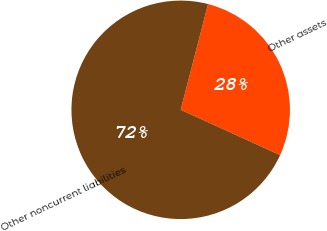<chart> <loc_0><loc_0><loc_500><loc_500><pie_chart><fcel>Other assets<fcel>Other noncurrent liabilities<nl><fcel>27.78%<fcel>72.22%<nl></chart> 